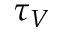Convert formula to latex. <formula><loc_0><loc_0><loc_500><loc_500>\tau _ { V }</formula> 